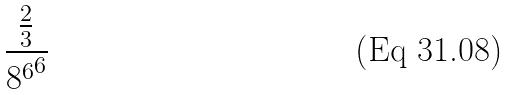<formula> <loc_0><loc_0><loc_500><loc_500>\frac { \frac { 2 } { 3 } } { { 8 ^ { 6 } } ^ { 6 } }</formula> 